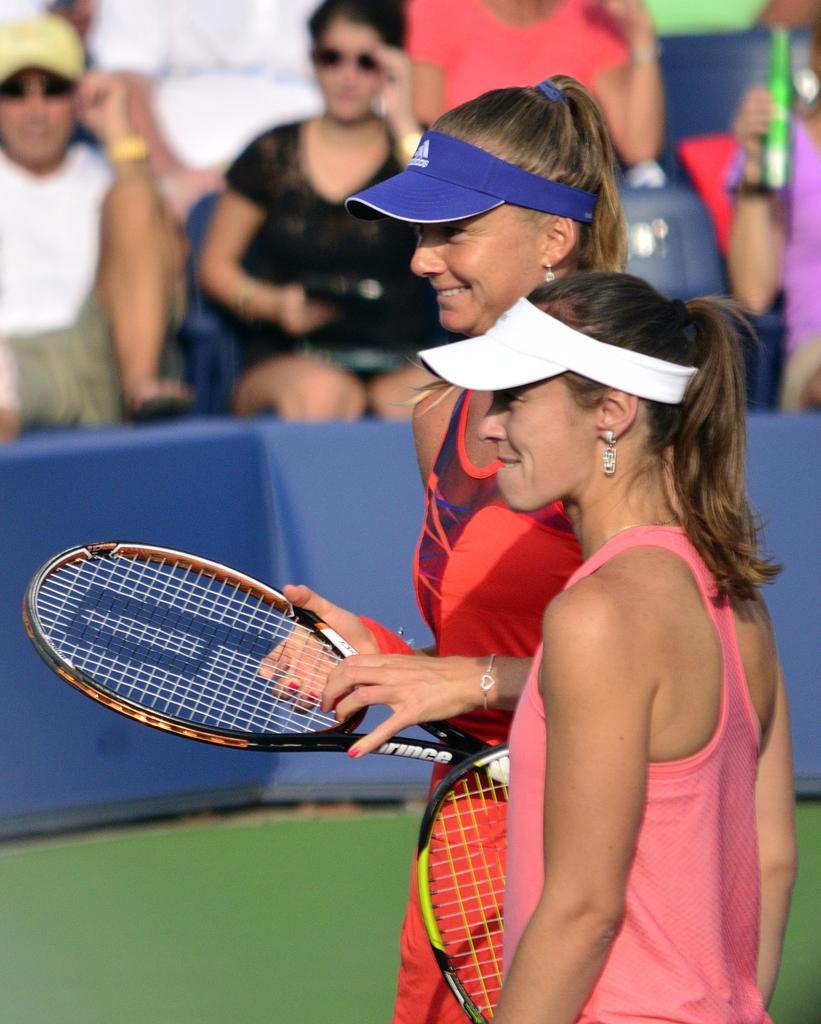How would you summarize this image in a sentence or two? In the image we can see there are women who are standing and they are holding rackets in their hand. 